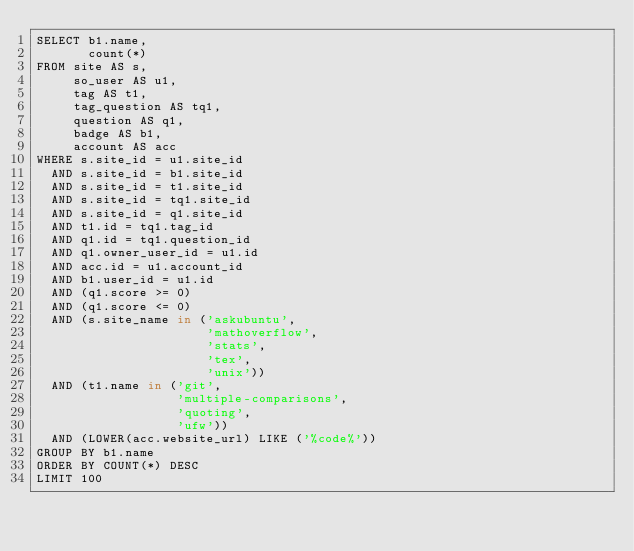Convert code to text. <code><loc_0><loc_0><loc_500><loc_500><_SQL_>SELECT b1.name,
       count(*)
FROM site AS s,
     so_user AS u1,
     tag AS t1,
     tag_question AS tq1,
     question AS q1,
     badge AS b1,
     account AS acc
WHERE s.site_id = u1.site_id
  AND s.site_id = b1.site_id
  AND s.site_id = t1.site_id
  AND s.site_id = tq1.site_id
  AND s.site_id = q1.site_id
  AND t1.id = tq1.tag_id
  AND q1.id = tq1.question_id
  AND q1.owner_user_id = u1.id
  AND acc.id = u1.account_id
  AND b1.user_id = u1.id
  AND (q1.score >= 0)
  AND (q1.score <= 0)
  AND (s.site_name in ('askubuntu',
                       'mathoverflow',
                       'stats',
                       'tex',
                       'unix'))
  AND (t1.name in ('git',
                   'multiple-comparisons',
                   'quoting',
                   'ufw'))
  AND (LOWER(acc.website_url) LIKE ('%code%'))
GROUP BY b1.name
ORDER BY COUNT(*) DESC
LIMIT 100</code> 